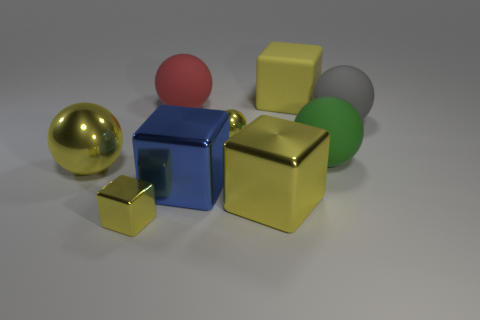Can you describe the texture and material appearance of the objects in the image? Certainly, the objects in the image appear to have a variety of textures. The golden sphere and the blue cube have reflective, smooth surfaces suggesting a metallic texture. The yellow cubes have a matte finish, consistent with a rubbery texture, while the red sphere and the green cylinder look to have a slightly less reflective, possibly plastic-like surface. 